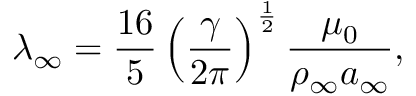<formula> <loc_0><loc_0><loc_500><loc_500>\lambda _ { \infty } = \frac { 1 6 } { 5 } \left ( \frac { \gamma } { 2 \pi } \right ) ^ { \frac { 1 } { 2 } } \frac { \mu _ { 0 } } { \rho _ { \infty } a _ { \infty } } ,</formula> 